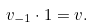Convert formula to latex. <formula><loc_0><loc_0><loc_500><loc_500>v _ { - 1 } \cdot 1 = v .</formula> 